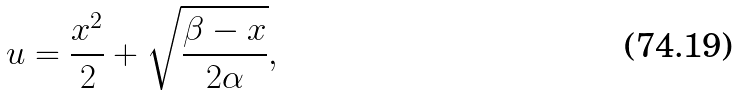<formula> <loc_0><loc_0><loc_500><loc_500>u = \frac { x ^ { 2 } } { 2 } + \sqrt { \frac { \beta - x } { 2 \alpha } } ,</formula> 